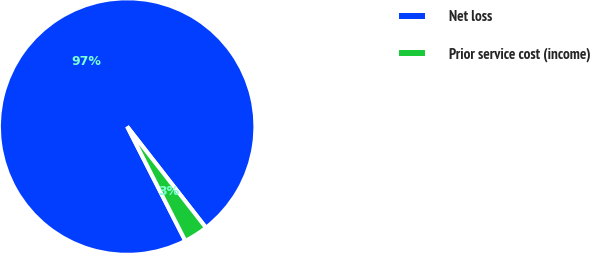Convert chart. <chart><loc_0><loc_0><loc_500><loc_500><pie_chart><fcel>Net loss<fcel>Prior service cost (income)<nl><fcel>96.96%<fcel>3.04%<nl></chart> 